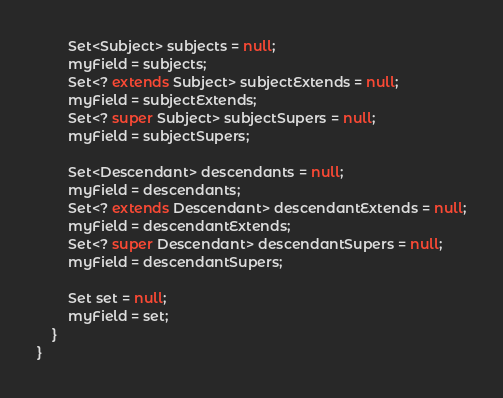<code> <loc_0><loc_0><loc_500><loc_500><_Java_>		Set<Subject> subjects = null;
		myField = subjects;
		Set<? extends Subject> subjectExtends = null;
		myField = subjectExtends;
		Set<? super Subject> subjectSupers = null;
		myField = subjectSupers;

		Set<Descendant> descendants = null;
		myField = descendants;
		Set<? extends Descendant> descendantExtends = null;
		myField = descendantExtends;
		Set<? super Descendant> descendantSupers = null;
		myField = descendantSupers;

		Set set = null;
		myField = set;
	}
}
</code> 